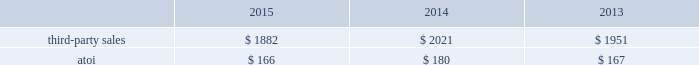Third-party sales for this segment increased 4% ( 4 % ) in 2014 compared with 2013 , primarily due to higher volumes and the acquisition of firth rixson ( $ 81 2014see above ) .
The higher volumes were mostly related to the aerospace ( commercial ) and commercial transportation end markets , somewhat offset by lower volumes in the industrial gas turbine end market .
Atoi for the engineered products and solutions segment increased $ 16 in 2015 compared with 2014 , principally the result of net productivity improvements across most businesses , a positive contribution from inorganic growth , and overall higher volumes in this segment 2019s organic businesses .
These positive impacts were partially offset by unfavorable price/product mix , higher costs related to growth projects , and net unfavorable foreign currency movements , primarily related to a weaker euro .
Atoi for this segment climbed $ 10 in 2014 compared with 2013 , mainly due to net productivity improvements across all businesses and overall higher volumes , partially offset by higher costs , primarily labor , and unfavorable product in 2016 , demand in the commercial aerospace end market is expected to remain strong , driven by significant order backlog .
Also , third-party sales will include a positive impact due to a full year of sales related to the acquisitions of rti and tital .
Additionally , net productivity improvements are anticipated while pricing pressure across all markets is expected .
Transportation and construction solutions .
This segment represents a portion of alcoa 2019s downstream operations and produces products that are used mostly in the nonresidential building and construction and commercial transportation end markets .
Such products include integrated aluminum structural systems , architectural extrusions , and forged aluminum commercial vehicle wheels , which are sold directly to customers and through distributors .
A small part of this segment also produces aluminum products for the industrial products end market .
Generally , the sales and costs and expenses of this segment are transacted in the local currency of the respective operations , which are mostly the u.s .
Dollar , the euro , and the brazilian real .
Third-party sales for the transportation and construction solutions segment decreased 7% ( 7 % ) in 2015 compared with 2014 , primarily driven by unfavorable foreign currency movements , principally caused by a weaker euro and brazilian real , and lower volume related to the building and construction end market , somewhat offset by higher volume related to the commercial transportation end market .
Third-party sales for this segment increased 4% ( 4 % ) in 2014 compared with 2013 , mostly the result of higher volume related to the commercial transportation and building and construction end markets , somewhat offset by lower volume in the industrial products and market .
Atoi for the transportation and construction solutions segment declined $ 14 in 2015 compared with 2014 , mainly due to higher costs , net unfavorable foreign currency movements , primarily related to a weaker euro and brazilian real , and unfavorable price/product mix .
These negative impacts were mostly offset by net productivity improvements across all businesses .
Atoi for this segment improved $ 13 in 2014 compared with 2013 , principally attributable to net productivity improvements across all businesses and overall higher volumes , partially offset by unfavorable product mix and higher costs , primarily labor .
In 2016 , the non-residential building and construction end market is expected to improve through growth in north america but will be slightly offset by overall weakness in europe .
Also , north america build rates in the commercial .
Considering the 2013-2014 period , what is the percentual improvement of net productivity and overall higher volumes concerning the atoi? 
Rationale: it is the value attributable to net productivity improvements and overall higher volumes divided by the total atoi in 2013 , then turned into a percentage .
Computations: ((13 / 167) * 100)
Answer: 7.78443. 